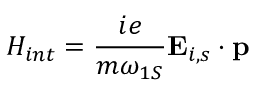Convert formula to latex. <formula><loc_0><loc_0><loc_500><loc_500>H _ { i n t } = \frac { i e } { m \omega _ { 1 S } } { E } _ { i , s } \cdot { p }</formula> 